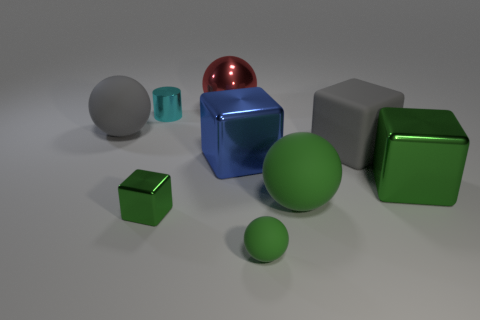Are the big ball that is on the left side of the cylinder and the large green thing right of the big green rubber thing made of the same material?
Your answer should be compact. No. There is a tiny metallic object in front of the cyan metal thing; what is its shape?
Your answer should be compact. Cube. What size is the other green thing that is the same shape as the large green shiny thing?
Your answer should be very brief. Small. Is the color of the rubber block the same as the metallic cylinder?
Your answer should be very brief. No. Is there anything else that is the same shape as the cyan metal object?
Provide a succinct answer. No. Is there a small object that is on the left side of the large green metallic cube right of the tiny cylinder?
Your response must be concise. Yes. What color is the other tiny thing that is the same shape as the red thing?
Provide a short and direct response. Green. How many large balls are the same color as the small matte ball?
Your answer should be very brief. 1. There is a large sphere that is behind the gray thing that is to the left of the metallic cube to the left of the big red ball; what color is it?
Your answer should be very brief. Red. Is the tiny cyan cylinder made of the same material as the large green block?
Keep it short and to the point. Yes. 